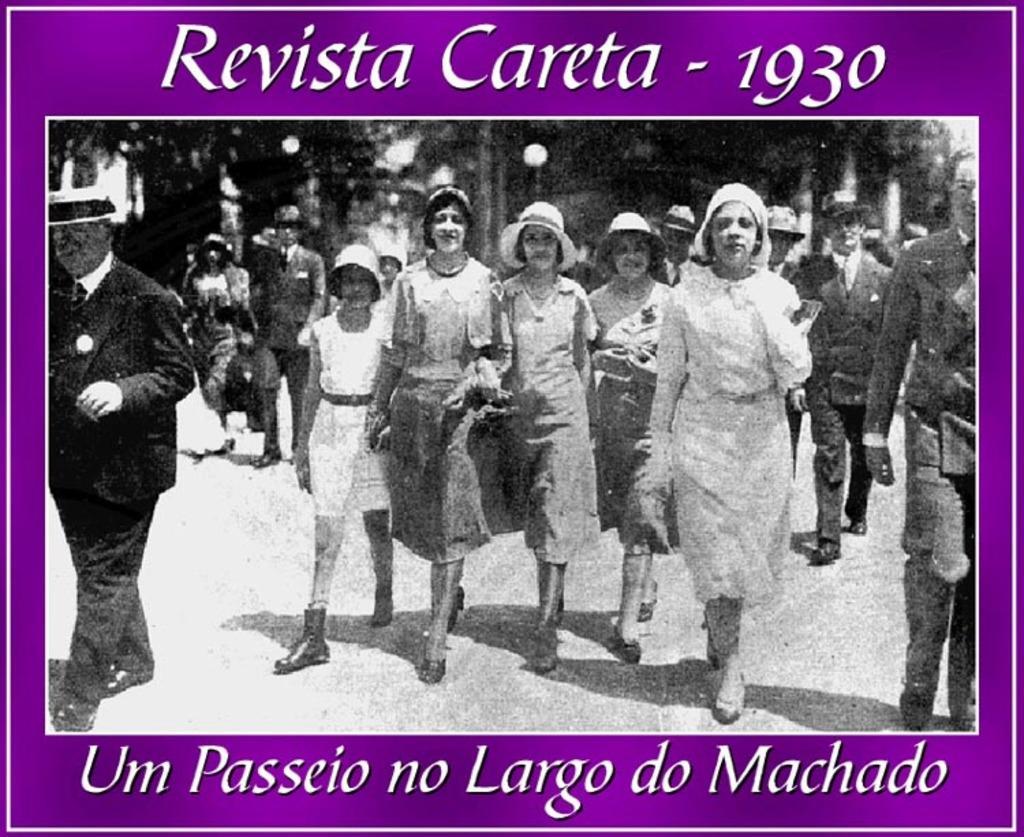Could you give a brief overview of what you see in this image? This is a black and white image we can see few persons are walking on the ground, trees and houses. At the top and bottom we can see texts written on the image. 